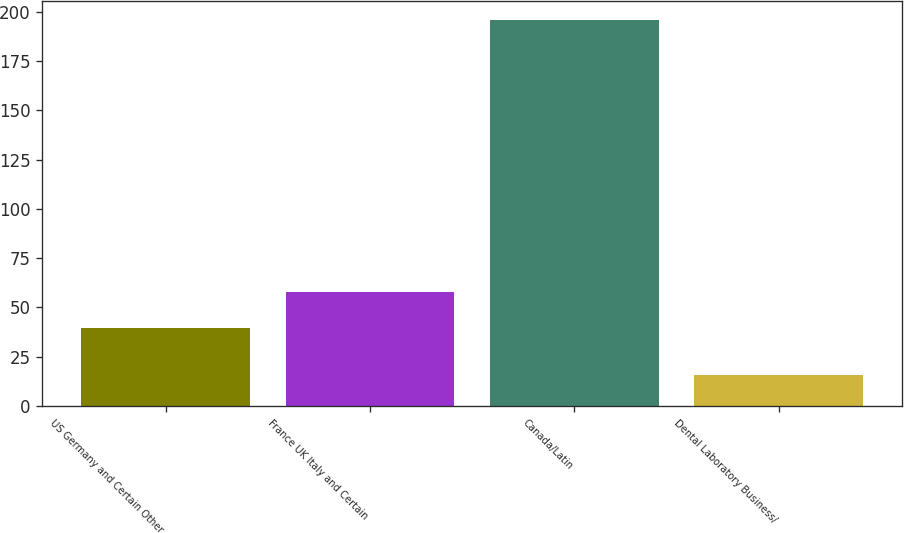<chart> <loc_0><loc_0><loc_500><loc_500><bar_chart><fcel>US Germany and Certain Other<fcel>France UK Italy and Certain<fcel>Canada/Latin<fcel>Dental Laboratory Business/<nl><fcel>39.7<fcel>57.69<fcel>195.8<fcel>15.9<nl></chart> 